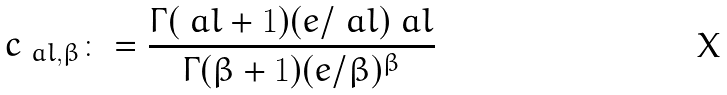Convert formula to latex. <formula><loc_0><loc_0><loc_500><loc_500>c _ { \ a l , \beta } \colon = \frac { \Gamma ( \ a l + 1 ) ( e / \ a l ) ^ { \ } a l } { \Gamma ( \beta + 1 ) ( e / \beta ) ^ { \beta } }</formula> 